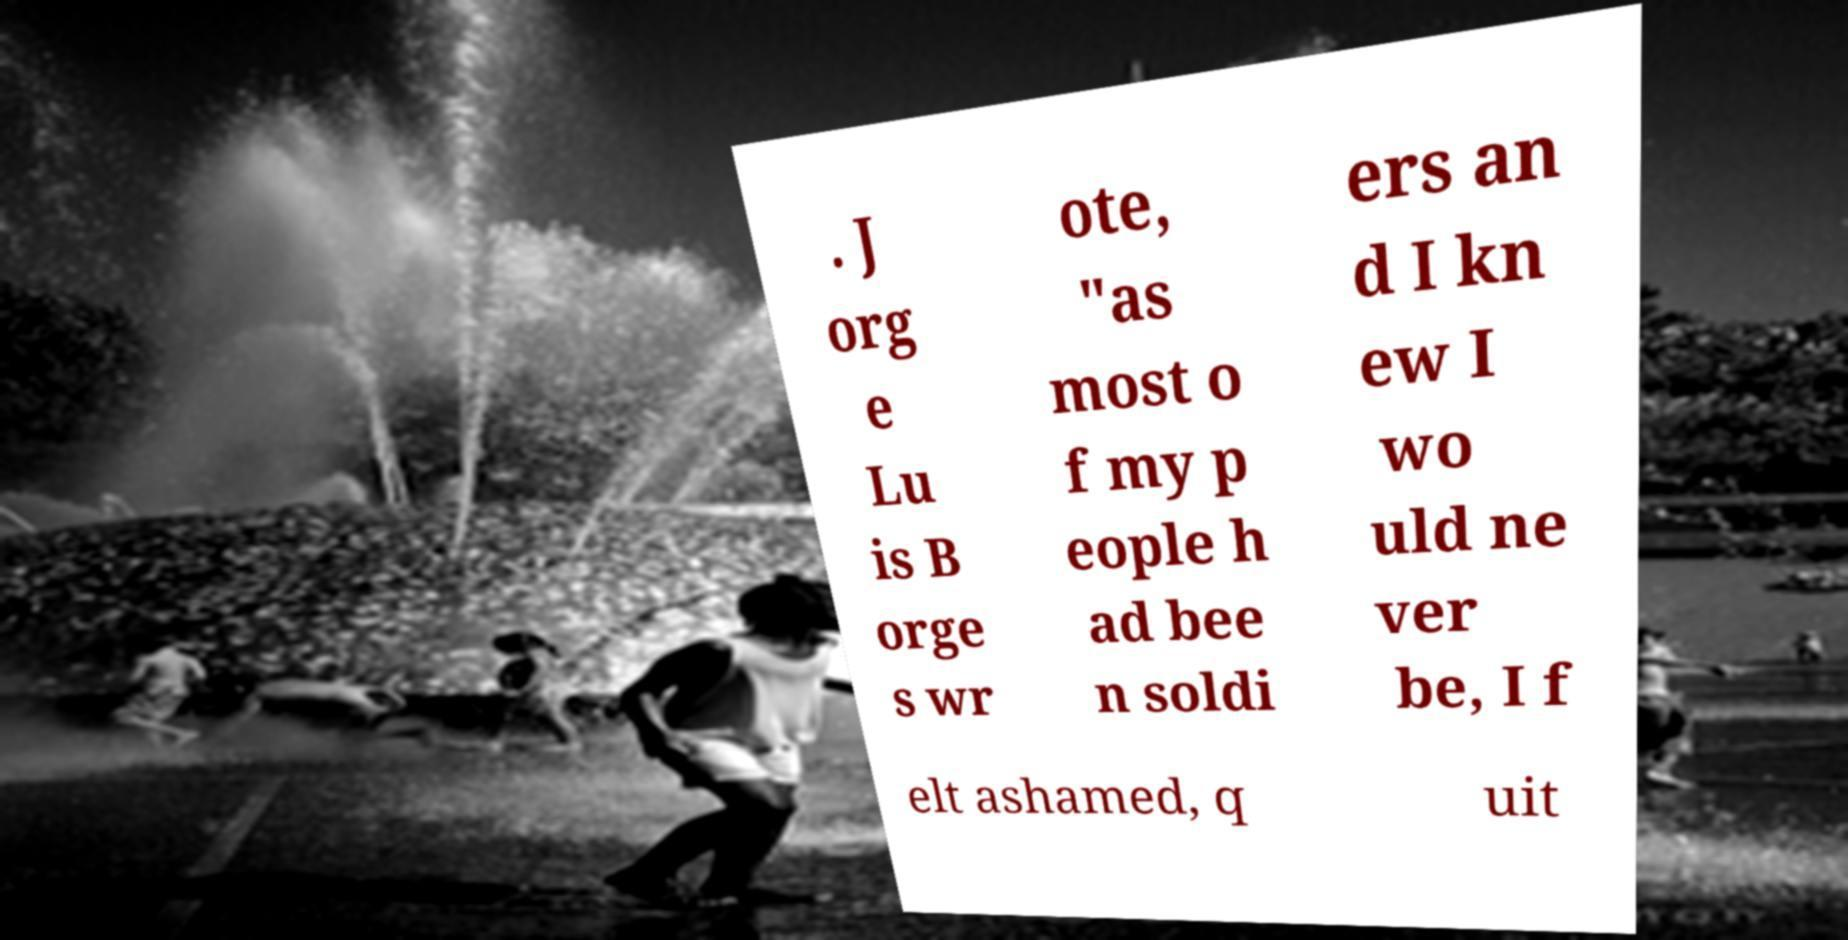Could you extract and type out the text from this image? . J org e Lu is B orge s wr ote, "as most o f my p eople h ad bee n soldi ers an d I kn ew I wo uld ne ver be, I f elt ashamed, q uit 